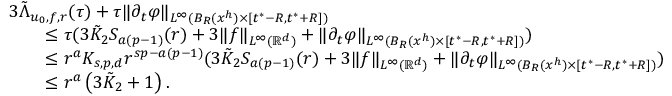<formula> <loc_0><loc_0><loc_500><loc_500>\begin{array} { r l } & { 3 \tilde { \Lambda } _ { u _ { 0 } , f , r } ( \tau ) + \tau \| \partial _ { t } \varphi \| _ { L ^ { \infty } ( B _ { R } ( x ^ { h } ) \times [ t ^ { * } - R , t ^ { * } + R ] ) } } \\ & { \quad \leq \tau ( 3 \tilde { K } _ { 2 } S _ { a ( p - 1 ) } ( r ) + 3 \| f \| _ { L ^ { \infty } ( { \mathbb { R } } ^ { d } ) } + \| \partial _ { t } \varphi \| _ { L ^ { \infty } ( B _ { R } ( x ^ { h } ) \times [ t ^ { * } - R , t ^ { * } + R ] ) } ) } \\ & { \quad \leq r ^ { a } K _ { s , p , d } r ^ { s p - a ( p - 1 ) } ( 3 \tilde { K } _ { 2 } S _ { a ( p - 1 ) } ( r ) + 3 \| f \| _ { L ^ { \infty } ( { \mathbb { R } } ^ { d } ) } + \| \partial _ { t } \varphi \| _ { L ^ { \infty } ( B _ { R } ( x ^ { h } ) \times [ t ^ { * } - R , t ^ { * } + R ] ) } ) } \\ & { \quad \leq r ^ { a } \left ( { 3 \tilde { K } _ { 2 } + 1 } \right ) . } \end{array}</formula> 